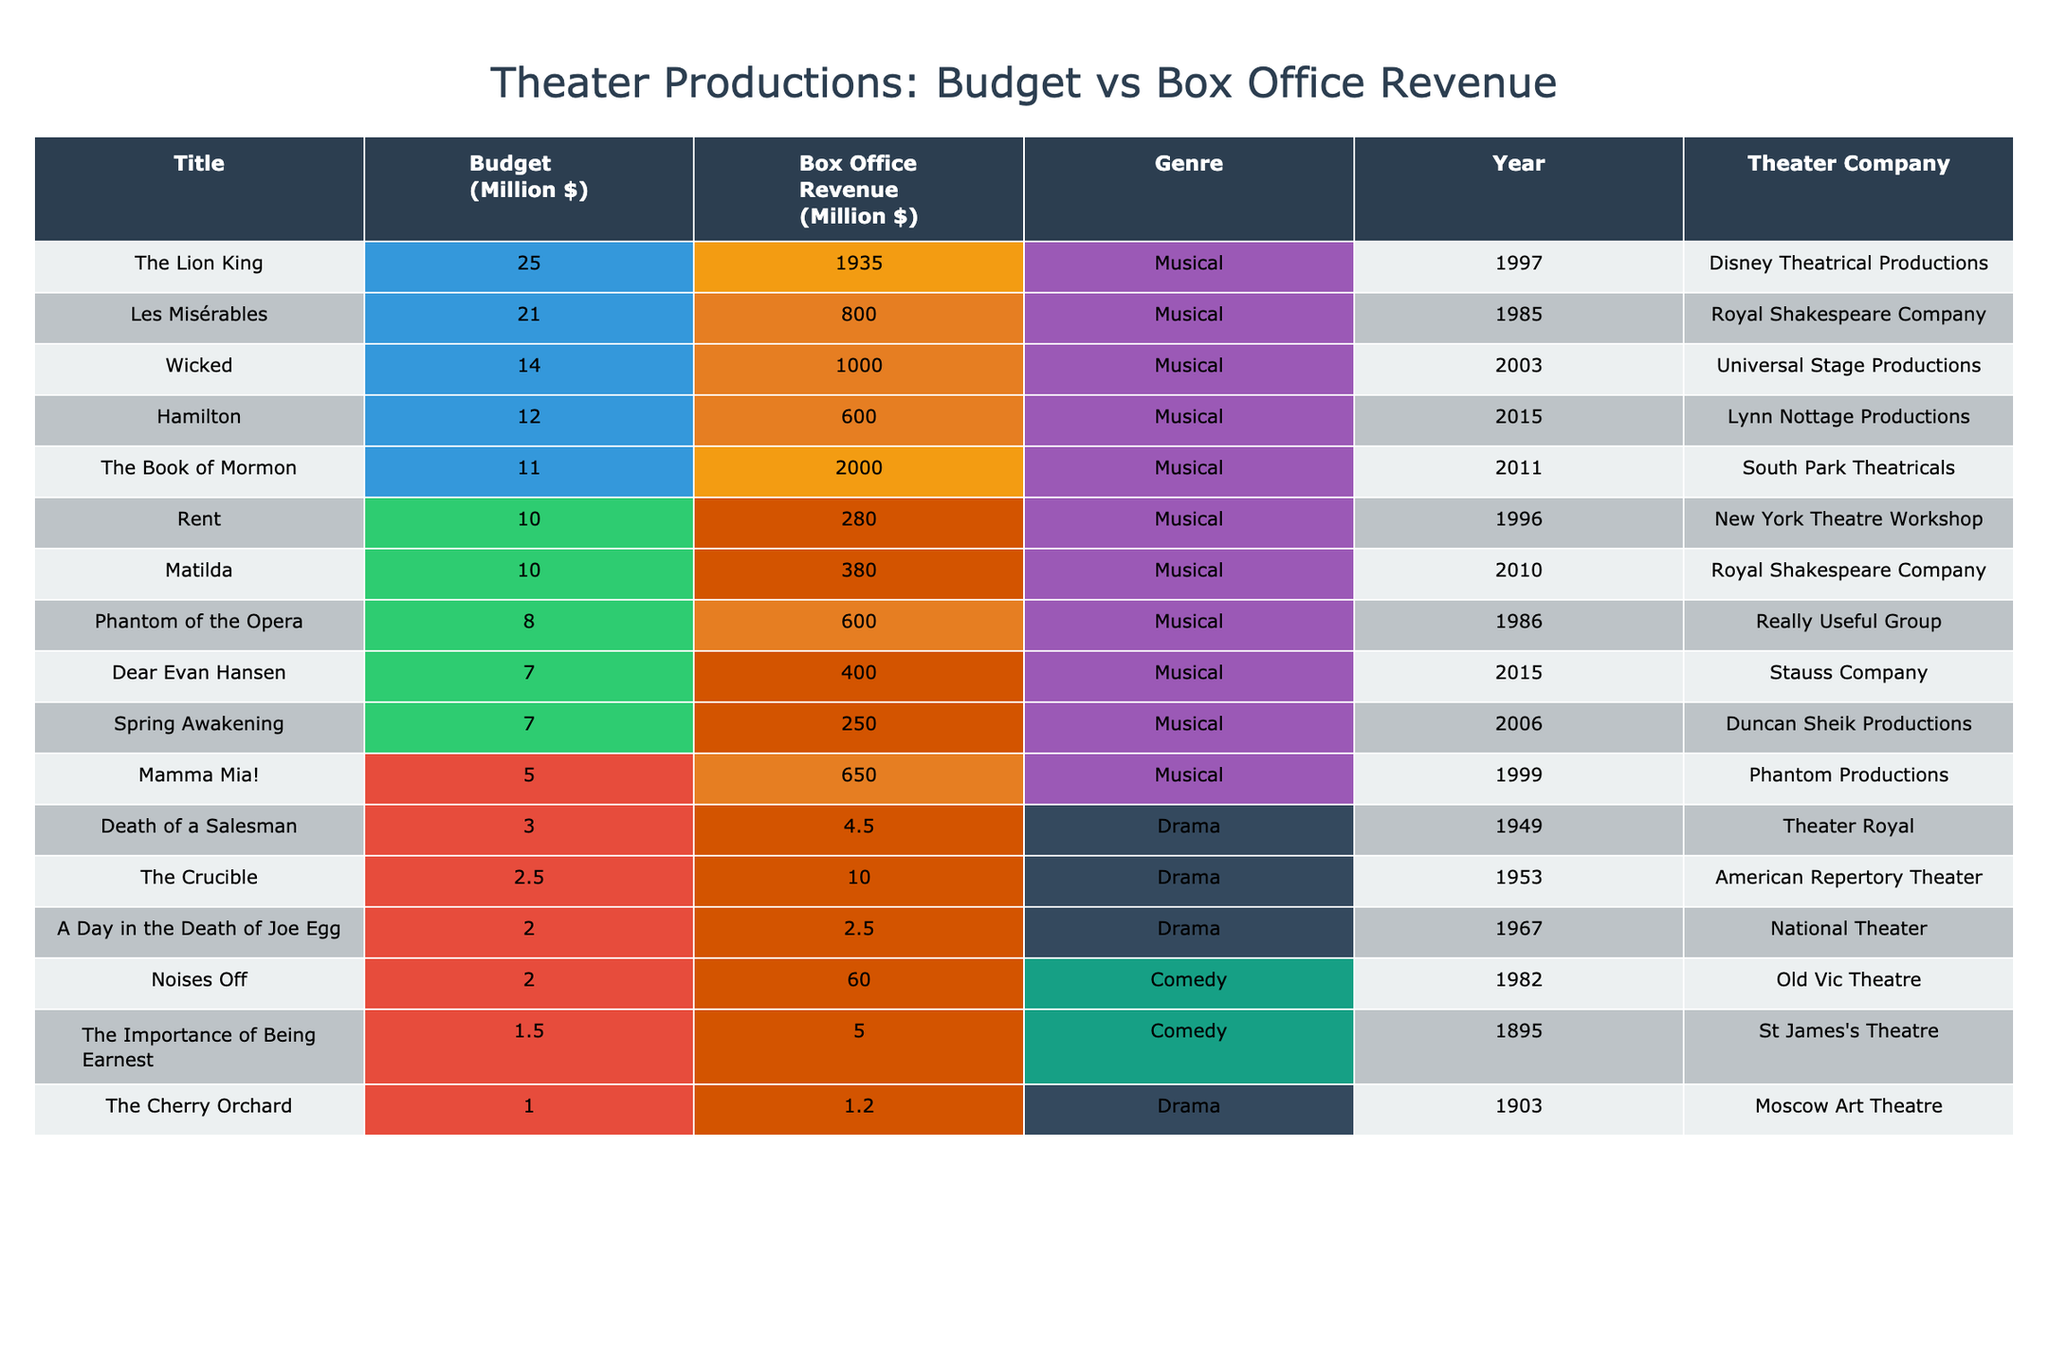What is the budget of "The Lion King"? The table lists "The Lion King" with a budget of 25 million dollars under the "Budget (Million $)" column.
Answer: 25 million dollars How much box office revenue did "Hamilton" generate? According to the table, "Hamilton" generated a box office revenue of 600 million dollars, as stated in the "Box Office Revenue (Million $)" column.
Answer: 600 million dollars Which production had the lowest box office revenue? By reviewing the "Box Office Revenue (Million $)" column, "A Day in the Death of Joe Egg" has the lowest revenue of 2.5 million dollars compared to others.
Answer: A Day in the Death of Joe Egg What is the average budget of all musical productions? To find this, first, identify the budgets of all musical productions: 12, 25, 14, 7, 11, 21, 8, 5, 10, 7, 10 (which sums to 152), then divide by the total number of musical productions (11). The average budget is 152/11 ≈ 13.82 million dollars.
Answer: Approximately 13.82 million dollars Did any production with a budget less than 5 million dollars make over 100 million in box office revenue? There are no productions listed with a budget less than 5 million dollars in the table, hence this question can be answered as no.
Answer: No Which genre has the highest average box office revenue based on the listed productions? Calculate the average box office revenue for each genre: Musical (from the values provided, the average is (600 + 1935 + 1000 + 400 + 2000 + 800 + 600 + 650 + 280 + 250 + 380) / 11 = 670 million dollars), Drama ((2.5 + 4.5 + 1.2 + 10) / 4 = 4.55 million dollars), and Comedy (60 + 5 / 2 = 32.5 million dollars). The musical genre has the highest average box office revenue of approximately 670 million dollars.
Answer: Musical How many productions from Disney Theatrical Productions are listed? Checking the table, "The Lion King" is the only production listed from Disney Theatrical Productions, confirming it is one.
Answer: One production What was the box office revenue for the production with the highest budget? The production with the highest budget is "The Lion King," which earned a box office revenue of 1935 million dollars according to the table.
Answer: 1935 million dollars Is "Les Misérables" the only production listed before the year 2000? Checking the years listed for "Les Misérables" (1985) reveals that there are other productions like "Death of a Salesman" (1949) and "The Importance of Being Earnest" (1895) that also precede 2000. So, it's not the only production.
Answer: No 